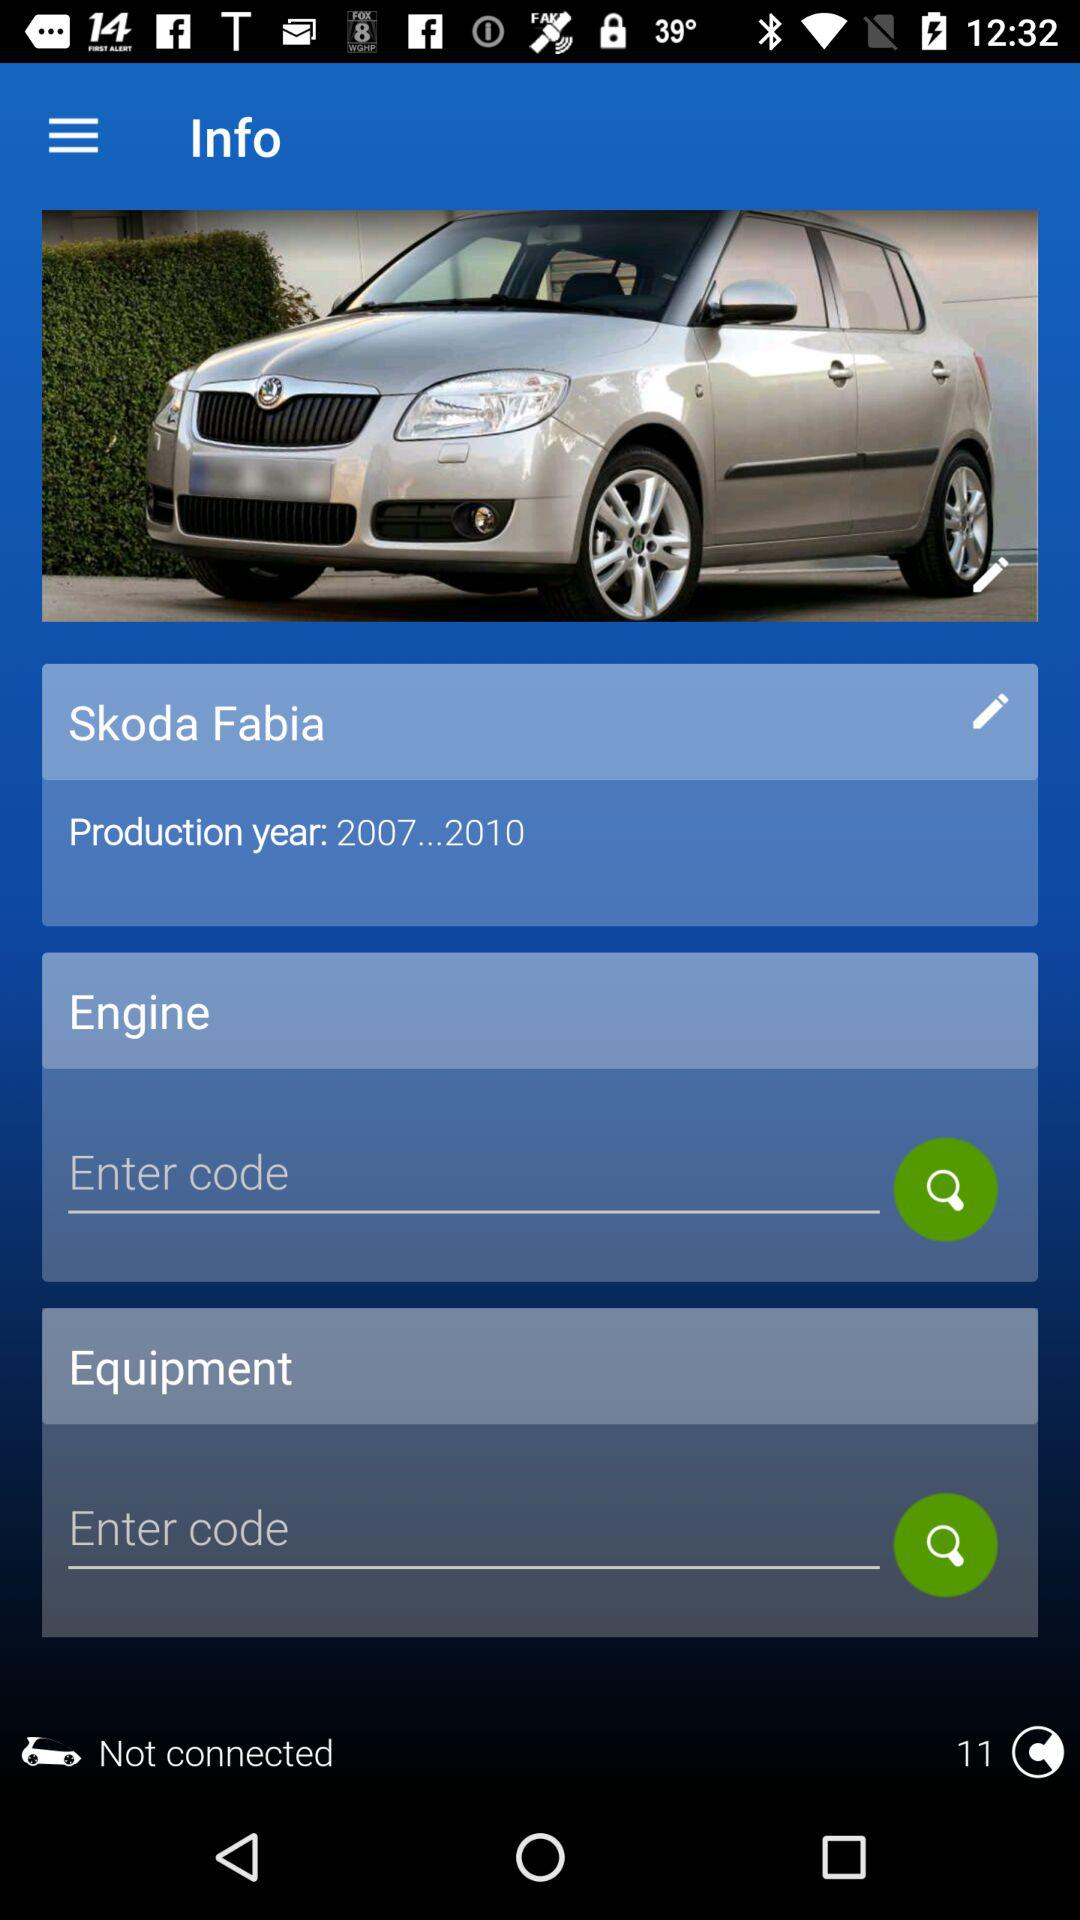What is the car name? The car name is Skoda Fabia. 